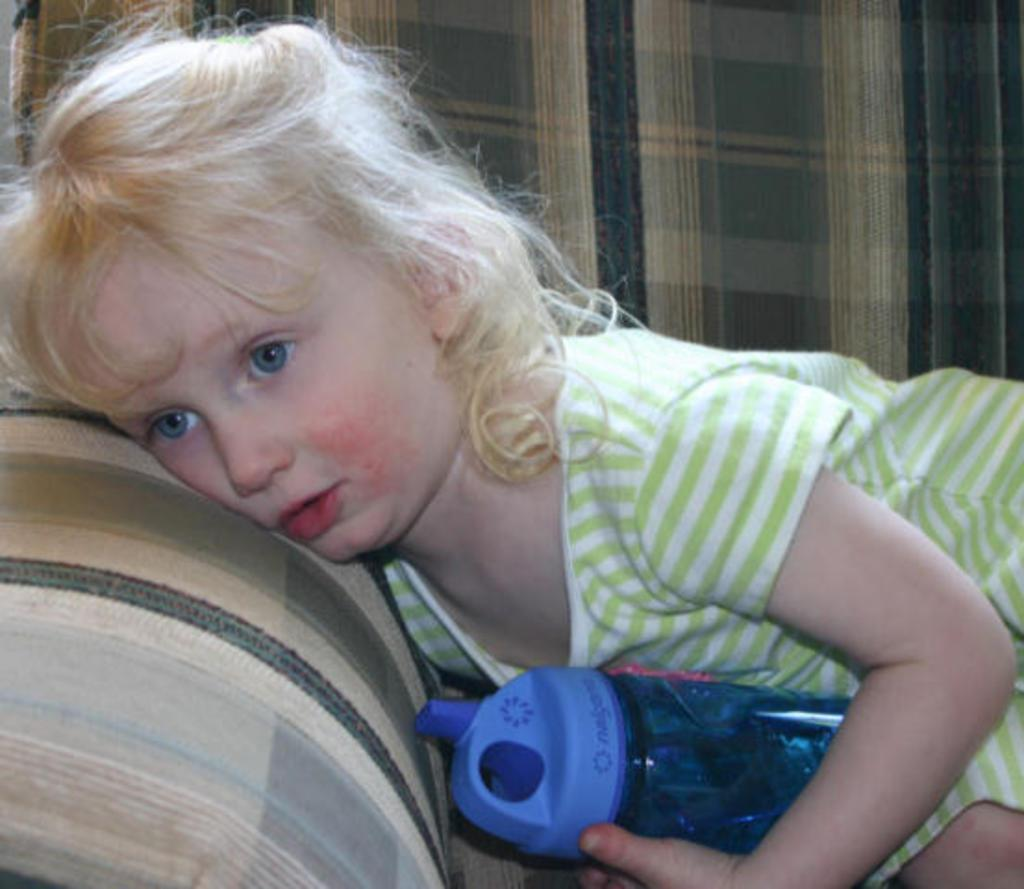Who is the main subject in the image? There is a girl in the image. What is the girl holding in the image? The girl is holding a bottle. What is the girl's position in the image? The girl is laying on a couch. How many frogs can be seen hopping around the girl in the image? There are no frogs present in the image. What type of owl is perched on the girl's shoulder in the image? There is no owl present in the image. 